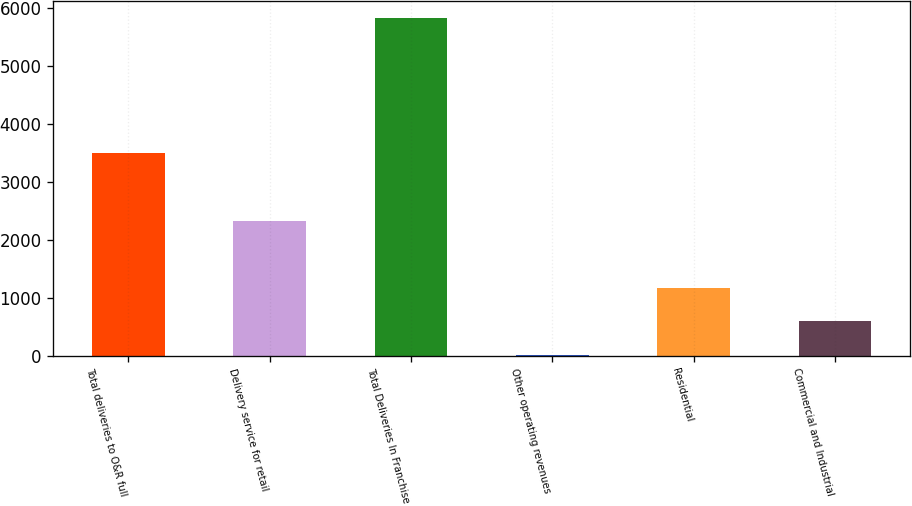Convert chart. <chart><loc_0><loc_0><loc_500><loc_500><bar_chart><fcel>Total deliveries to O&R full<fcel>Delivery service for retail<fcel>Total Deliveries In Franchise<fcel>Other operating revenues<fcel>Residential<fcel>Commercial and Industrial<nl><fcel>3498<fcel>2330<fcel>5828<fcel>10<fcel>1173.6<fcel>591.8<nl></chart> 